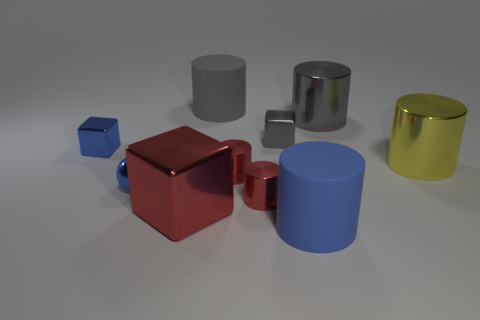Is the number of balls on the right side of the big blue rubber cylinder less than the number of big gray matte cylinders?
Your answer should be compact. Yes. Are there any gray shiny things that have the same size as the blue sphere?
Make the answer very short. Yes. There is a ball that is the same material as the red block; what is its color?
Keep it short and to the point. Blue. What number of blue rubber cylinders are right of the rubber cylinder that is to the right of the gray rubber thing?
Your answer should be compact. 0. The block that is both on the right side of the small sphere and behind the small ball is made of what material?
Ensure brevity in your answer.  Metal. There is a small blue metal thing behind the small blue metal sphere; is its shape the same as the yellow metallic object?
Make the answer very short. No. Are there fewer large red metallic things than large green blocks?
Keep it short and to the point. No. How many large metallic objects are the same color as the ball?
Keep it short and to the point. 0. There is a tiny cube that is the same color as the small sphere; what material is it?
Provide a short and direct response. Metal. There is a large block; does it have the same color as the rubber cylinder that is behind the blue matte object?
Ensure brevity in your answer.  No. 